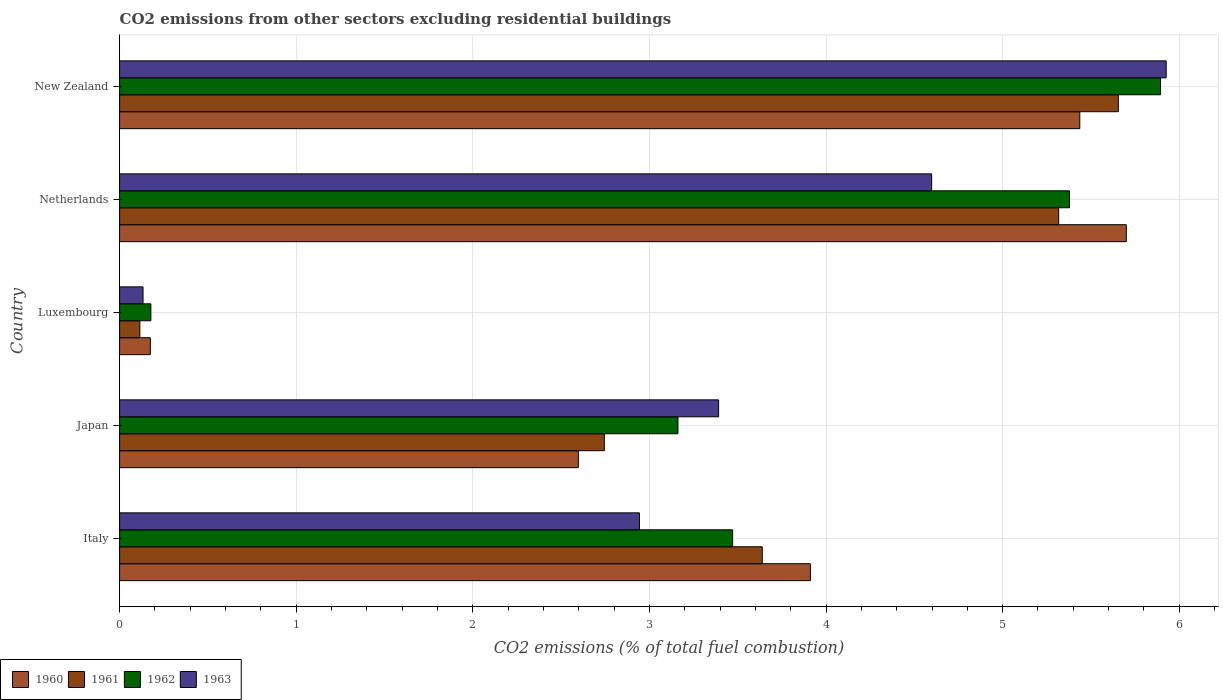How many bars are there on the 2nd tick from the top?
Offer a very short reply. 4. What is the label of the 2nd group of bars from the top?
Make the answer very short. Netherlands. What is the total CO2 emitted in 1962 in Luxembourg?
Provide a succinct answer. 0.18. Across all countries, what is the maximum total CO2 emitted in 1962?
Provide a succinct answer. 5.89. Across all countries, what is the minimum total CO2 emitted in 1962?
Ensure brevity in your answer.  0.18. In which country was the total CO2 emitted in 1963 maximum?
Make the answer very short. New Zealand. In which country was the total CO2 emitted in 1963 minimum?
Your answer should be compact. Luxembourg. What is the total total CO2 emitted in 1960 in the graph?
Offer a terse response. 17.82. What is the difference between the total CO2 emitted in 1961 in Italy and that in Luxembourg?
Offer a very short reply. 3.52. What is the difference between the total CO2 emitted in 1963 in Italy and the total CO2 emitted in 1961 in New Zealand?
Offer a very short reply. -2.71. What is the average total CO2 emitted in 1961 per country?
Make the answer very short. 3.49. What is the difference between the total CO2 emitted in 1960 and total CO2 emitted in 1961 in New Zealand?
Offer a terse response. -0.22. In how many countries, is the total CO2 emitted in 1963 greater than 2.6 ?
Provide a short and direct response. 4. What is the ratio of the total CO2 emitted in 1961 in Italy to that in Luxembourg?
Give a very brief answer. 31.75. Is the total CO2 emitted in 1962 in Luxembourg less than that in Netherlands?
Give a very brief answer. Yes. What is the difference between the highest and the second highest total CO2 emitted in 1961?
Make the answer very short. 0.34. What is the difference between the highest and the lowest total CO2 emitted in 1961?
Ensure brevity in your answer.  5.54. Is the sum of the total CO2 emitted in 1963 in Japan and New Zealand greater than the maximum total CO2 emitted in 1962 across all countries?
Keep it short and to the point. Yes. Is it the case that in every country, the sum of the total CO2 emitted in 1961 and total CO2 emitted in 1962 is greater than the sum of total CO2 emitted in 1963 and total CO2 emitted in 1960?
Keep it short and to the point. No. What does the 1st bar from the bottom in Italy represents?
Your answer should be very brief. 1960. Is it the case that in every country, the sum of the total CO2 emitted in 1961 and total CO2 emitted in 1960 is greater than the total CO2 emitted in 1962?
Your response must be concise. Yes. Are all the bars in the graph horizontal?
Ensure brevity in your answer.  Yes. How many countries are there in the graph?
Offer a terse response. 5. What is the difference between two consecutive major ticks on the X-axis?
Make the answer very short. 1. Does the graph contain any zero values?
Provide a short and direct response. No. Where does the legend appear in the graph?
Ensure brevity in your answer.  Bottom left. How many legend labels are there?
Make the answer very short. 4. How are the legend labels stacked?
Provide a succinct answer. Horizontal. What is the title of the graph?
Give a very brief answer. CO2 emissions from other sectors excluding residential buildings. What is the label or title of the X-axis?
Give a very brief answer. CO2 emissions (% of total fuel combustion). What is the label or title of the Y-axis?
Your response must be concise. Country. What is the CO2 emissions (% of total fuel combustion) in 1960 in Italy?
Ensure brevity in your answer.  3.91. What is the CO2 emissions (% of total fuel combustion) in 1961 in Italy?
Keep it short and to the point. 3.64. What is the CO2 emissions (% of total fuel combustion) in 1962 in Italy?
Your answer should be very brief. 3.47. What is the CO2 emissions (% of total fuel combustion) in 1963 in Italy?
Make the answer very short. 2.94. What is the CO2 emissions (% of total fuel combustion) of 1960 in Japan?
Your response must be concise. 2.6. What is the CO2 emissions (% of total fuel combustion) in 1961 in Japan?
Give a very brief answer. 2.74. What is the CO2 emissions (% of total fuel combustion) in 1962 in Japan?
Keep it short and to the point. 3.16. What is the CO2 emissions (% of total fuel combustion) of 1963 in Japan?
Your answer should be very brief. 3.39. What is the CO2 emissions (% of total fuel combustion) of 1960 in Luxembourg?
Offer a terse response. 0.17. What is the CO2 emissions (% of total fuel combustion) in 1961 in Luxembourg?
Offer a very short reply. 0.11. What is the CO2 emissions (% of total fuel combustion) of 1962 in Luxembourg?
Offer a very short reply. 0.18. What is the CO2 emissions (% of total fuel combustion) of 1963 in Luxembourg?
Make the answer very short. 0.13. What is the CO2 emissions (% of total fuel combustion) of 1960 in Netherlands?
Your response must be concise. 5.7. What is the CO2 emissions (% of total fuel combustion) of 1961 in Netherlands?
Make the answer very short. 5.32. What is the CO2 emissions (% of total fuel combustion) in 1962 in Netherlands?
Your answer should be compact. 5.38. What is the CO2 emissions (% of total fuel combustion) of 1963 in Netherlands?
Make the answer very short. 4.6. What is the CO2 emissions (% of total fuel combustion) in 1960 in New Zealand?
Provide a short and direct response. 5.44. What is the CO2 emissions (% of total fuel combustion) in 1961 in New Zealand?
Provide a short and direct response. 5.66. What is the CO2 emissions (% of total fuel combustion) in 1962 in New Zealand?
Your response must be concise. 5.89. What is the CO2 emissions (% of total fuel combustion) of 1963 in New Zealand?
Give a very brief answer. 5.93. Across all countries, what is the maximum CO2 emissions (% of total fuel combustion) in 1960?
Offer a terse response. 5.7. Across all countries, what is the maximum CO2 emissions (% of total fuel combustion) of 1961?
Offer a terse response. 5.66. Across all countries, what is the maximum CO2 emissions (% of total fuel combustion) in 1962?
Make the answer very short. 5.89. Across all countries, what is the maximum CO2 emissions (% of total fuel combustion) of 1963?
Make the answer very short. 5.93. Across all countries, what is the minimum CO2 emissions (% of total fuel combustion) of 1960?
Give a very brief answer. 0.17. Across all countries, what is the minimum CO2 emissions (% of total fuel combustion) in 1961?
Provide a succinct answer. 0.11. Across all countries, what is the minimum CO2 emissions (% of total fuel combustion) of 1962?
Offer a very short reply. 0.18. Across all countries, what is the minimum CO2 emissions (% of total fuel combustion) in 1963?
Offer a terse response. 0.13. What is the total CO2 emissions (% of total fuel combustion) of 1960 in the graph?
Give a very brief answer. 17.82. What is the total CO2 emissions (% of total fuel combustion) in 1961 in the graph?
Offer a very short reply. 17.47. What is the total CO2 emissions (% of total fuel combustion) of 1962 in the graph?
Make the answer very short. 18.08. What is the total CO2 emissions (% of total fuel combustion) of 1963 in the graph?
Provide a succinct answer. 16.99. What is the difference between the CO2 emissions (% of total fuel combustion) in 1960 in Italy and that in Japan?
Provide a succinct answer. 1.31. What is the difference between the CO2 emissions (% of total fuel combustion) in 1961 in Italy and that in Japan?
Give a very brief answer. 0.89. What is the difference between the CO2 emissions (% of total fuel combustion) of 1962 in Italy and that in Japan?
Give a very brief answer. 0.31. What is the difference between the CO2 emissions (% of total fuel combustion) in 1963 in Italy and that in Japan?
Your response must be concise. -0.45. What is the difference between the CO2 emissions (% of total fuel combustion) of 1960 in Italy and that in Luxembourg?
Provide a succinct answer. 3.74. What is the difference between the CO2 emissions (% of total fuel combustion) of 1961 in Italy and that in Luxembourg?
Make the answer very short. 3.52. What is the difference between the CO2 emissions (% of total fuel combustion) in 1962 in Italy and that in Luxembourg?
Make the answer very short. 3.29. What is the difference between the CO2 emissions (% of total fuel combustion) of 1963 in Italy and that in Luxembourg?
Provide a succinct answer. 2.81. What is the difference between the CO2 emissions (% of total fuel combustion) in 1960 in Italy and that in Netherlands?
Offer a terse response. -1.79. What is the difference between the CO2 emissions (% of total fuel combustion) in 1961 in Italy and that in Netherlands?
Keep it short and to the point. -1.68. What is the difference between the CO2 emissions (% of total fuel combustion) in 1962 in Italy and that in Netherlands?
Your answer should be very brief. -1.91. What is the difference between the CO2 emissions (% of total fuel combustion) in 1963 in Italy and that in Netherlands?
Your response must be concise. -1.65. What is the difference between the CO2 emissions (% of total fuel combustion) in 1960 in Italy and that in New Zealand?
Offer a terse response. -1.53. What is the difference between the CO2 emissions (% of total fuel combustion) in 1961 in Italy and that in New Zealand?
Keep it short and to the point. -2.02. What is the difference between the CO2 emissions (% of total fuel combustion) in 1962 in Italy and that in New Zealand?
Keep it short and to the point. -2.42. What is the difference between the CO2 emissions (% of total fuel combustion) in 1963 in Italy and that in New Zealand?
Your answer should be compact. -2.98. What is the difference between the CO2 emissions (% of total fuel combustion) in 1960 in Japan and that in Luxembourg?
Your answer should be compact. 2.42. What is the difference between the CO2 emissions (% of total fuel combustion) in 1961 in Japan and that in Luxembourg?
Your response must be concise. 2.63. What is the difference between the CO2 emissions (% of total fuel combustion) in 1962 in Japan and that in Luxembourg?
Make the answer very short. 2.98. What is the difference between the CO2 emissions (% of total fuel combustion) of 1963 in Japan and that in Luxembourg?
Your answer should be very brief. 3.26. What is the difference between the CO2 emissions (% of total fuel combustion) of 1960 in Japan and that in Netherlands?
Give a very brief answer. -3.1. What is the difference between the CO2 emissions (% of total fuel combustion) in 1961 in Japan and that in Netherlands?
Offer a very short reply. -2.57. What is the difference between the CO2 emissions (% of total fuel combustion) in 1962 in Japan and that in Netherlands?
Your response must be concise. -2.22. What is the difference between the CO2 emissions (% of total fuel combustion) of 1963 in Japan and that in Netherlands?
Your response must be concise. -1.21. What is the difference between the CO2 emissions (% of total fuel combustion) in 1960 in Japan and that in New Zealand?
Offer a terse response. -2.84. What is the difference between the CO2 emissions (% of total fuel combustion) in 1961 in Japan and that in New Zealand?
Offer a very short reply. -2.91. What is the difference between the CO2 emissions (% of total fuel combustion) in 1962 in Japan and that in New Zealand?
Offer a terse response. -2.73. What is the difference between the CO2 emissions (% of total fuel combustion) of 1963 in Japan and that in New Zealand?
Offer a very short reply. -2.53. What is the difference between the CO2 emissions (% of total fuel combustion) in 1960 in Luxembourg and that in Netherlands?
Ensure brevity in your answer.  -5.53. What is the difference between the CO2 emissions (% of total fuel combustion) in 1961 in Luxembourg and that in Netherlands?
Provide a succinct answer. -5.2. What is the difference between the CO2 emissions (% of total fuel combustion) in 1962 in Luxembourg and that in Netherlands?
Your answer should be very brief. -5.2. What is the difference between the CO2 emissions (% of total fuel combustion) in 1963 in Luxembourg and that in Netherlands?
Ensure brevity in your answer.  -4.47. What is the difference between the CO2 emissions (% of total fuel combustion) of 1960 in Luxembourg and that in New Zealand?
Your answer should be compact. -5.26. What is the difference between the CO2 emissions (% of total fuel combustion) in 1961 in Luxembourg and that in New Zealand?
Your response must be concise. -5.54. What is the difference between the CO2 emissions (% of total fuel combustion) of 1962 in Luxembourg and that in New Zealand?
Ensure brevity in your answer.  -5.72. What is the difference between the CO2 emissions (% of total fuel combustion) in 1963 in Luxembourg and that in New Zealand?
Provide a short and direct response. -5.79. What is the difference between the CO2 emissions (% of total fuel combustion) in 1960 in Netherlands and that in New Zealand?
Provide a succinct answer. 0.26. What is the difference between the CO2 emissions (% of total fuel combustion) of 1961 in Netherlands and that in New Zealand?
Provide a short and direct response. -0.34. What is the difference between the CO2 emissions (% of total fuel combustion) in 1962 in Netherlands and that in New Zealand?
Make the answer very short. -0.52. What is the difference between the CO2 emissions (% of total fuel combustion) of 1963 in Netherlands and that in New Zealand?
Keep it short and to the point. -1.33. What is the difference between the CO2 emissions (% of total fuel combustion) of 1960 in Italy and the CO2 emissions (% of total fuel combustion) of 1961 in Japan?
Offer a very short reply. 1.17. What is the difference between the CO2 emissions (% of total fuel combustion) in 1960 in Italy and the CO2 emissions (% of total fuel combustion) in 1962 in Japan?
Provide a short and direct response. 0.75. What is the difference between the CO2 emissions (% of total fuel combustion) in 1960 in Italy and the CO2 emissions (% of total fuel combustion) in 1963 in Japan?
Keep it short and to the point. 0.52. What is the difference between the CO2 emissions (% of total fuel combustion) of 1961 in Italy and the CO2 emissions (% of total fuel combustion) of 1962 in Japan?
Give a very brief answer. 0.48. What is the difference between the CO2 emissions (% of total fuel combustion) of 1961 in Italy and the CO2 emissions (% of total fuel combustion) of 1963 in Japan?
Your answer should be compact. 0.25. What is the difference between the CO2 emissions (% of total fuel combustion) of 1962 in Italy and the CO2 emissions (% of total fuel combustion) of 1963 in Japan?
Provide a short and direct response. 0.08. What is the difference between the CO2 emissions (% of total fuel combustion) of 1960 in Italy and the CO2 emissions (% of total fuel combustion) of 1961 in Luxembourg?
Provide a succinct answer. 3.8. What is the difference between the CO2 emissions (% of total fuel combustion) in 1960 in Italy and the CO2 emissions (% of total fuel combustion) in 1962 in Luxembourg?
Offer a very short reply. 3.73. What is the difference between the CO2 emissions (% of total fuel combustion) in 1960 in Italy and the CO2 emissions (% of total fuel combustion) in 1963 in Luxembourg?
Offer a very short reply. 3.78. What is the difference between the CO2 emissions (% of total fuel combustion) in 1961 in Italy and the CO2 emissions (% of total fuel combustion) in 1962 in Luxembourg?
Provide a short and direct response. 3.46. What is the difference between the CO2 emissions (% of total fuel combustion) in 1961 in Italy and the CO2 emissions (% of total fuel combustion) in 1963 in Luxembourg?
Offer a very short reply. 3.51. What is the difference between the CO2 emissions (% of total fuel combustion) of 1962 in Italy and the CO2 emissions (% of total fuel combustion) of 1963 in Luxembourg?
Give a very brief answer. 3.34. What is the difference between the CO2 emissions (% of total fuel combustion) of 1960 in Italy and the CO2 emissions (% of total fuel combustion) of 1961 in Netherlands?
Your response must be concise. -1.41. What is the difference between the CO2 emissions (% of total fuel combustion) in 1960 in Italy and the CO2 emissions (% of total fuel combustion) in 1962 in Netherlands?
Provide a short and direct response. -1.47. What is the difference between the CO2 emissions (% of total fuel combustion) of 1960 in Italy and the CO2 emissions (% of total fuel combustion) of 1963 in Netherlands?
Your answer should be compact. -0.69. What is the difference between the CO2 emissions (% of total fuel combustion) of 1961 in Italy and the CO2 emissions (% of total fuel combustion) of 1962 in Netherlands?
Offer a terse response. -1.74. What is the difference between the CO2 emissions (% of total fuel combustion) of 1961 in Italy and the CO2 emissions (% of total fuel combustion) of 1963 in Netherlands?
Keep it short and to the point. -0.96. What is the difference between the CO2 emissions (% of total fuel combustion) of 1962 in Italy and the CO2 emissions (% of total fuel combustion) of 1963 in Netherlands?
Your response must be concise. -1.13. What is the difference between the CO2 emissions (% of total fuel combustion) in 1960 in Italy and the CO2 emissions (% of total fuel combustion) in 1961 in New Zealand?
Your answer should be very brief. -1.74. What is the difference between the CO2 emissions (% of total fuel combustion) in 1960 in Italy and the CO2 emissions (% of total fuel combustion) in 1962 in New Zealand?
Provide a succinct answer. -1.98. What is the difference between the CO2 emissions (% of total fuel combustion) in 1960 in Italy and the CO2 emissions (% of total fuel combustion) in 1963 in New Zealand?
Keep it short and to the point. -2.01. What is the difference between the CO2 emissions (% of total fuel combustion) in 1961 in Italy and the CO2 emissions (% of total fuel combustion) in 1962 in New Zealand?
Your answer should be very brief. -2.26. What is the difference between the CO2 emissions (% of total fuel combustion) of 1961 in Italy and the CO2 emissions (% of total fuel combustion) of 1963 in New Zealand?
Keep it short and to the point. -2.29. What is the difference between the CO2 emissions (% of total fuel combustion) in 1962 in Italy and the CO2 emissions (% of total fuel combustion) in 1963 in New Zealand?
Offer a very short reply. -2.45. What is the difference between the CO2 emissions (% of total fuel combustion) in 1960 in Japan and the CO2 emissions (% of total fuel combustion) in 1961 in Luxembourg?
Keep it short and to the point. 2.48. What is the difference between the CO2 emissions (% of total fuel combustion) of 1960 in Japan and the CO2 emissions (% of total fuel combustion) of 1962 in Luxembourg?
Your answer should be very brief. 2.42. What is the difference between the CO2 emissions (% of total fuel combustion) in 1960 in Japan and the CO2 emissions (% of total fuel combustion) in 1963 in Luxembourg?
Offer a very short reply. 2.46. What is the difference between the CO2 emissions (% of total fuel combustion) in 1961 in Japan and the CO2 emissions (% of total fuel combustion) in 1962 in Luxembourg?
Provide a short and direct response. 2.57. What is the difference between the CO2 emissions (% of total fuel combustion) of 1961 in Japan and the CO2 emissions (% of total fuel combustion) of 1963 in Luxembourg?
Ensure brevity in your answer.  2.61. What is the difference between the CO2 emissions (% of total fuel combustion) in 1962 in Japan and the CO2 emissions (% of total fuel combustion) in 1963 in Luxembourg?
Give a very brief answer. 3.03. What is the difference between the CO2 emissions (% of total fuel combustion) of 1960 in Japan and the CO2 emissions (% of total fuel combustion) of 1961 in Netherlands?
Provide a short and direct response. -2.72. What is the difference between the CO2 emissions (% of total fuel combustion) of 1960 in Japan and the CO2 emissions (% of total fuel combustion) of 1962 in Netherlands?
Keep it short and to the point. -2.78. What is the difference between the CO2 emissions (% of total fuel combustion) of 1960 in Japan and the CO2 emissions (% of total fuel combustion) of 1963 in Netherlands?
Give a very brief answer. -2. What is the difference between the CO2 emissions (% of total fuel combustion) of 1961 in Japan and the CO2 emissions (% of total fuel combustion) of 1962 in Netherlands?
Provide a short and direct response. -2.63. What is the difference between the CO2 emissions (% of total fuel combustion) of 1961 in Japan and the CO2 emissions (% of total fuel combustion) of 1963 in Netherlands?
Provide a succinct answer. -1.85. What is the difference between the CO2 emissions (% of total fuel combustion) of 1962 in Japan and the CO2 emissions (% of total fuel combustion) of 1963 in Netherlands?
Offer a terse response. -1.44. What is the difference between the CO2 emissions (% of total fuel combustion) of 1960 in Japan and the CO2 emissions (% of total fuel combustion) of 1961 in New Zealand?
Offer a very short reply. -3.06. What is the difference between the CO2 emissions (% of total fuel combustion) in 1960 in Japan and the CO2 emissions (% of total fuel combustion) in 1962 in New Zealand?
Give a very brief answer. -3.3. What is the difference between the CO2 emissions (% of total fuel combustion) of 1960 in Japan and the CO2 emissions (% of total fuel combustion) of 1963 in New Zealand?
Provide a short and direct response. -3.33. What is the difference between the CO2 emissions (% of total fuel combustion) in 1961 in Japan and the CO2 emissions (% of total fuel combustion) in 1962 in New Zealand?
Ensure brevity in your answer.  -3.15. What is the difference between the CO2 emissions (% of total fuel combustion) of 1961 in Japan and the CO2 emissions (% of total fuel combustion) of 1963 in New Zealand?
Give a very brief answer. -3.18. What is the difference between the CO2 emissions (% of total fuel combustion) of 1962 in Japan and the CO2 emissions (% of total fuel combustion) of 1963 in New Zealand?
Offer a terse response. -2.76. What is the difference between the CO2 emissions (% of total fuel combustion) of 1960 in Luxembourg and the CO2 emissions (% of total fuel combustion) of 1961 in Netherlands?
Your answer should be very brief. -5.14. What is the difference between the CO2 emissions (% of total fuel combustion) in 1960 in Luxembourg and the CO2 emissions (% of total fuel combustion) in 1962 in Netherlands?
Make the answer very short. -5.2. What is the difference between the CO2 emissions (% of total fuel combustion) in 1960 in Luxembourg and the CO2 emissions (% of total fuel combustion) in 1963 in Netherlands?
Keep it short and to the point. -4.42. What is the difference between the CO2 emissions (% of total fuel combustion) of 1961 in Luxembourg and the CO2 emissions (% of total fuel combustion) of 1962 in Netherlands?
Give a very brief answer. -5.26. What is the difference between the CO2 emissions (% of total fuel combustion) of 1961 in Luxembourg and the CO2 emissions (% of total fuel combustion) of 1963 in Netherlands?
Your answer should be compact. -4.48. What is the difference between the CO2 emissions (% of total fuel combustion) of 1962 in Luxembourg and the CO2 emissions (% of total fuel combustion) of 1963 in Netherlands?
Give a very brief answer. -4.42. What is the difference between the CO2 emissions (% of total fuel combustion) of 1960 in Luxembourg and the CO2 emissions (% of total fuel combustion) of 1961 in New Zealand?
Ensure brevity in your answer.  -5.48. What is the difference between the CO2 emissions (% of total fuel combustion) of 1960 in Luxembourg and the CO2 emissions (% of total fuel combustion) of 1962 in New Zealand?
Give a very brief answer. -5.72. What is the difference between the CO2 emissions (% of total fuel combustion) of 1960 in Luxembourg and the CO2 emissions (% of total fuel combustion) of 1963 in New Zealand?
Provide a succinct answer. -5.75. What is the difference between the CO2 emissions (% of total fuel combustion) of 1961 in Luxembourg and the CO2 emissions (% of total fuel combustion) of 1962 in New Zealand?
Your response must be concise. -5.78. What is the difference between the CO2 emissions (% of total fuel combustion) of 1961 in Luxembourg and the CO2 emissions (% of total fuel combustion) of 1963 in New Zealand?
Your response must be concise. -5.81. What is the difference between the CO2 emissions (% of total fuel combustion) of 1962 in Luxembourg and the CO2 emissions (% of total fuel combustion) of 1963 in New Zealand?
Your answer should be very brief. -5.75. What is the difference between the CO2 emissions (% of total fuel combustion) of 1960 in Netherlands and the CO2 emissions (% of total fuel combustion) of 1961 in New Zealand?
Keep it short and to the point. 0.05. What is the difference between the CO2 emissions (% of total fuel combustion) in 1960 in Netherlands and the CO2 emissions (% of total fuel combustion) in 1962 in New Zealand?
Provide a succinct answer. -0.19. What is the difference between the CO2 emissions (% of total fuel combustion) in 1960 in Netherlands and the CO2 emissions (% of total fuel combustion) in 1963 in New Zealand?
Offer a terse response. -0.23. What is the difference between the CO2 emissions (% of total fuel combustion) in 1961 in Netherlands and the CO2 emissions (% of total fuel combustion) in 1962 in New Zealand?
Keep it short and to the point. -0.58. What is the difference between the CO2 emissions (% of total fuel combustion) of 1961 in Netherlands and the CO2 emissions (% of total fuel combustion) of 1963 in New Zealand?
Provide a succinct answer. -0.61. What is the difference between the CO2 emissions (% of total fuel combustion) of 1962 in Netherlands and the CO2 emissions (% of total fuel combustion) of 1963 in New Zealand?
Your answer should be compact. -0.55. What is the average CO2 emissions (% of total fuel combustion) in 1960 per country?
Ensure brevity in your answer.  3.56. What is the average CO2 emissions (% of total fuel combustion) of 1961 per country?
Your response must be concise. 3.49. What is the average CO2 emissions (% of total fuel combustion) of 1962 per country?
Your answer should be compact. 3.62. What is the average CO2 emissions (% of total fuel combustion) in 1963 per country?
Give a very brief answer. 3.4. What is the difference between the CO2 emissions (% of total fuel combustion) in 1960 and CO2 emissions (% of total fuel combustion) in 1961 in Italy?
Provide a succinct answer. 0.27. What is the difference between the CO2 emissions (% of total fuel combustion) in 1960 and CO2 emissions (% of total fuel combustion) in 1962 in Italy?
Your answer should be very brief. 0.44. What is the difference between the CO2 emissions (% of total fuel combustion) in 1960 and CO2 emissions (% of total fuel combustion) in 1963 in Italy?
Your answer should be very brief. 0.97. What is the difference between the CO2 emissions (% of total fuel combustion) in 1961 and CO2 emissions (% of total fuel combustion) in 1962 in Italy?
Keep it short and to the point. 0.17. What is the difference between the CO2 emissions (% of total fuel combustion) in 1961 and CO2 emissions (% of total fuel combustion) in 1963 in Italy?
Give a very brief answer. 0.7. What is the difference between the CO2 emissions (% of total fuel combustion) in 1962 and CO2 emissions (% of total fuel combustion) in 1963 in Italy?
Ensure brevity in your answer.  0.53. What is the difference between the CO2 emissions (% of total fuel combustion) in 1960 and CO2 emissions (% of total fuel combustion) in 1961 in Japan?
Offer a very short reply. -0.15. What is the difference between the CO2 emissions (% of total fuel combustion) of 1960 and CO2 emissions (% of total fuel combustion) of 1962 in Japan?
Provide a succinct answer. -0.56. What is the difference between the CO2 emissions (% of total fuel combustion) of 1960 and CO2 emissions (% of total fuel combustion) of 1963 in Japan?
Provide a succinct answer. -0.79. What is the difference between the CO2 emissions (% of total fuel combustion) of 1961 and CO2 emissions (% of total fuel combustion) of 1962 in Japan?
Your response must be concise. -0.42. What is the difference between the CO2 emissions (% of total fuel combustion) of 1961 and CO2 emissions (% of total fuel combustion) of 1963 in Japan?
Provide a short and direct response. -0.65. What is the difference between the CO2 emissions (% of total fuel combustion) of 1962 and CO2 emissions (% of total fuel combustion) of 1963 in Japan?
Your answer should be compact. -0.23. What is the difference between the CO2 emissions (% of total fuel combustion) of 1960 and CO2 emissions (% of total fuel combustion) of 1961 in Luxembourg?
Offer a very short reply. 0.06. What is the difference between the CO2 emissions (% of total fuel combustion) in 1960 and CO2 emissions (% of total fuel combustion) in 1962 in Luxembourg?
Your answer should be very brief. -0. What is the difference between the CO2 emissions (% of total fuel combustion) in 1960 and CO2 emissions (% of total fuel combustion) in 1963 in Luxembourg?
Keep it short and to the point. 0.04. What is the difference between the CO2 emissions (% of total fuel combustion) in 1961 and CO2 emissions (% of total fuel combustion) in 1962 in Luxembourg?
Offer a terse response. -0.06. What is the difference between the CO2 emissions (% of total fuel combustion) of 1961 and CO2 emissions (% of total fuel combustion) of 1963 in Luxembourg?
Ensure brevity in your answer.  -0.02. What is the difference between the CO2 emissions (% of total fuel combustion) of 1962 and CO2 emissions (% of total fuel combustion) of 1963 in Luxembourg?
Ensure brevity in your answer.  0.04. What is the difference between the CO2 emissions (% of total fuel combustion) in 1960 and CO2 emissions (% of total fuel combustion) in 1961 in Netherlands?
Your answer should be very brief. 0.38. What is the difference between the CO2 emissions (% of total fuel combustion) of 1960 and CO2 emissions (% of total fuel combustion) of 1962 in Netherlands?
Ensure brevity in your answer.  0.32. What is the difference between the CO2 emissions (% of total fuel combustion) in 1960 and CO2 emissions (% of total fuel combustion) in 1963 in Netherlands?
Your answer should be very brief. 1.1. What is the difference between the CO2 emissions (% of total fuel combustion) in 1961 and CO2 emissions (% of total fuel combustion) in 1962 in Netherlands?
Ensure brevity in your answer.  -0.06. What is the difference between the CO2 emissions (% of total fuel combustion) in 1961 and CO2 emissions (% of total fuel combustion) in 1963 in Netherlands?
Ensure brevity in your answer.  0.72. What is the difference between the CO2 emissions (% of total fuel combustion) of 1962 and CO2 emissions (% of total fuel combustion) of 1963 in Netherlands?
Your response must be concise. 0.78. What is the difference between the CO2 emissions (% of total fuel combustion) in 1960 and CO2 emissions (% of total fuel combustion) in 1961 in New Zealand?
Your response must be concise. -0.22. What is the difference between the CO2 emissions (% of total fuel combustion) of 1960 and CO2 emissions (% of total fuel combustion) of 1962 in New Zealand?
Your response must be concise. -0.46. What is the difference between the CO2 emissions (% of total fuel combustion) of 1960 and CO2 emissions (% of total fuel combustion) of 1963 in New Zealand?
Provide a short and direct response. -0.49. What is the difference between the CO2 emissions (% of total fuel combustion) in 1961 and CO2 emissions (% of total fuel combustion) in 1962 in New Zealand?
Provide a succinct answer. -0.24. What is the difference between the CO2 emissions (% of total fuel combustion) of 1961 and CO2 emissions (% of total fuel combustion) of 1963 in New Zealand?
Your answer should be compact. -0.27. What is the difference between the CO2 emissions (% of total fuel combustion) of 1962 and CO2 emissions (% of total fuel combustion) of 1963 in New Zealand?
Make the answer very short. -0.03. What is the ratio of the CO2 emissions (% of total fuel combustion) of 1960 in Italy to that in Japan?
Provide a succinct answer. 1.51. What is the ratio of the CO2 emissions (% of total fuel combustion) of 1961 in Italy to that in Japan?
Make the answer very short. 1.33. What is the ratio of the CO2 emissions (% of total fuel combustion) in 1962 in Italy to that in Japan?
Give a very brief answer. 1.1. What is the ratio of the CO2 emissions (% of total fuel combustion) of 1963 in Italy to that in Japan?
Give a very brief answer. 0.87. What is the ratio of the CO2 emissions (% of total fuel combustion) in 1960 in Italy to that in Luxembourg?
Ensure brevity in your answer.  22.48. What is the ratio of the CO2 emissions (% of total fuel combustion) of 1961 in Italy to that in Luxembourg?
Make the answer very short. 31.75. What is the ratio of the CO2 emissions (% of total fuel combustion) of 1962 in Italy to that in Luxembourg?
Make the answer very short. 19.6. What is the ratio of the CO2 emissions (% of total fuel combustion) in 1963 in Italy to that in Luxembourg?
Provide a succinct answer. 22.19. What is the ratio of the CO2 emissions (% of total fuel combustion) in 1960 in Italy to that in Netherlands?
Provide a short and direct response. 0.69. What is the ratio of the CO2 emissions (% of total fuel combustion) of 1961 in Italy to that in Netherlands?
Give a very brief answer. 0.68. What is the ratio of the CO2 emissions (% of total fuel combustion) of 1962 in Italy to that in Netherlands?
Ensure brevity in your answer.  0.65. What is the ratio of the CO2 emissions (% of total fuel combustion) in 1963 in Italy to that in Netherlands?
Offer a very short reply. 0.64. What is the ratio of the CO2 emissions (% of total fuel combustion) of 1960 in Italy to that in New Zealand?
Offer a terse response. 0.72. What is the ratio of the CO2 emissions (% of total fuel combustion) of 1961 in Italy to that in New Zealand?
Give a very brief answer. 0.64. What is the ratio of the CO2 emissions (% of total fuel combustion) in 1962 in Italy to that in New Zealand?
Provide a succinct answer. 0.59. What is the ratio of the CO2 emissions (% of total fuel combustion) of 1963 in Italy to that in New Zealand?
Your response must be concise. 0.5. What is the ratio of the CO2 emissions (% of total fuel combustion) in 1960 in Japan to that in Luxembourg?
Provide a short and direct response. 14.93. What is the ratio of the CO2 emissions (% of total fuel combustion) in 1961 in Japan to that in Luxembourg?
Provide a succinct answer. 23.95. What is the ratio of the CO2 emissions (% of total fuel combustion) in 1962 in Japan to that in Luxembourg?
Ensure brevity in your answer.  17.85. What is the ratio of the CO2 emissions (% of total fuel combustion) of 1963 in Japan to that in Luxembourg?
Ensure brevity in your answer.  25.57. What is the ratio of the CO2 emissions (% of total fuel combustion) of 1960 in Japan to that in Netherlands?
Provide a succinct answer. 0.46. What is the ratio of the CO2 emissions (% of total fuel combustion) in 1961 in Japan to that in Netherlands?
Your answer should be very brief. 0.52. What is the ratio of the CO2 emissions (% of total fuel combustion) in 1962 in Japan to that in Netherlands?
Make the answer very short. 0.59. What is the ratio of the CO2 emissions (% of total fuel combustion) of 1963 in Japan to that in Netherlands?
Your answer should be very brief. 0.74. What is the ratio of the CO2 emissions (% of total fuel combustion) in 1960 in Japan to that in New Zealand?
Ensure brevity in your answer.  0.48. What is the ratio of the CO2 emissions (% of total fuel combustion) in 1961 in Japan to that in New Zealand?
Your response must be concise. 0.49. What is the ratio of the CO2 emissions (% of total fuel combustion) of 1962 in Japan to that in New Zealand?
Give a very brief answer. 0.54. What is the ratio of the CO2 emissions (% of total fuel combustion) of 1963 in Japan to that in New Zealand?
Ensure brevity in your answer.  0.57. What is the ratio of the CO2 emissions (% of total fuel combustion) of 1960 in Luxembourg to that in Netherlands?
Your answer should be very brief. 0.03. What is the ratio of the CO2 emissions (% of total fuel combustion) of 1961 in Luxembourg to that in Netherlands?
Provide a succinct answer. 0.02. What is the ratio of the CO2 emissions (% of total fuel combustion) of 1962 in Luxembourg to that in Netherlands?
Provide a succinct answer. 0.03. What is the ratio of the CO2 emissions (% of total fuel combustion) in 1963 in Luxembourg to that in Netherlands?
Your answer should be compact. 0.03. What is the ratio of the CO2 emissions (% of total fuel combustion) of 1960 in Luxembourg to that in New Zealand?
Your response must be concise. 0.03. What is the ratio of the CO2 emissions (% of total fuel combustion) in 1961 in Luxembourg to that in New Zealand?
Your answer should be compact. 0.02. What is the ratio of the CO2 emissions (% of total fuel combustion) in 1962 in Luxembourg to that in New Zealand?
Provide a short and direct response. 0.03. What is the ratio of the CO2 emissions (% of total fuel combustion) in 1963 in Luxembourg to that in New Zealand?
Your answer should be compact. 0.02. What is the ratio of the CO2 emissions (% of total fuel combustion) of 1960 in Netherlands to that in New Zealand?
Offer a very short reply. 1.05. What is the ratio of the CO2 emissions (% of total fuel combustion) in 1961 in Netherlands to that in New Zealand?
Provide a short and direct response. 0.94. What is the ratio of the CO2 emissions (% of total fuel combustion) of 1962 in Netherlands to that in New Zealand?
Offer a terse response. 0.91. What is the ratio of the CO2 emissions (% of total fuel combustion) in 1963 in Netherlands to that in New Zealand?
Give a very brief answer. 0.78. What is the difference between the highest and the second highest CO2 emissions (% of total fuel combustion) of 1960?
Offer a terse response. 0.26. What is the difference between the highest and the second highest CO2 emissions (% of total fuel combustion) of 1961?
Provide a succinct answer. 0.34. What is the difference between the highest and the second highest CO2 emissions (% of total fuel combustion) of 1962?
Provide a short and direct response. 0.52. What is the difference between the highest and the second highest CO2 emissions (% of total fuel combustion) of 1963?
Provide a short and direct response. 1.33. What is the difference between the highest and the lowest CO2 emissions (% of total fuel combustion) in 1960?
Offer a terse response. 5.53. What is the difference between the highest and the lowest CO2 emissions (% of total fuel combustion) of 1961?
Your answer should be compact. 5.54. What is the difference between the highest and the lowest CO2 emissions (% of total fuel combustion) of 1962?
Provide a short and direct response. 5.72. What is the difference between the highest and the lowest CO2 emissions (% of total fuel combustion) in 1963?
Offer a terse response. 5.79. 